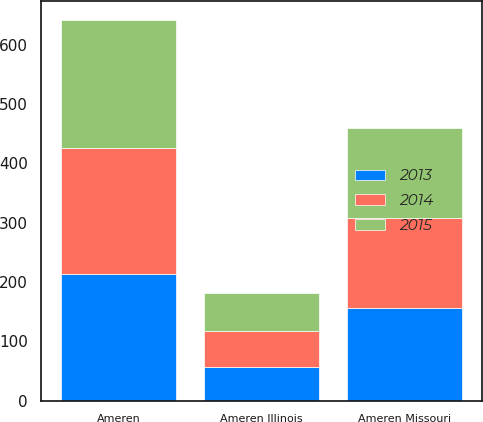Convert chart to OTSL. <chart><loc_0><loc_0><loc_500><loc_500><stacked_bar_chart><ecel><fcel>Ameren Missouri<fcel>Ameren Illinois<fcel>Ameren<nl><fcel>2013<fcel>156<fcel>57<fcel>213<nl><fcel>2015<fcel>151<fcel>64<fcel>215<nl><fcel>2014<fcel>152<fcel>61<fcel>213<nl></chart> 